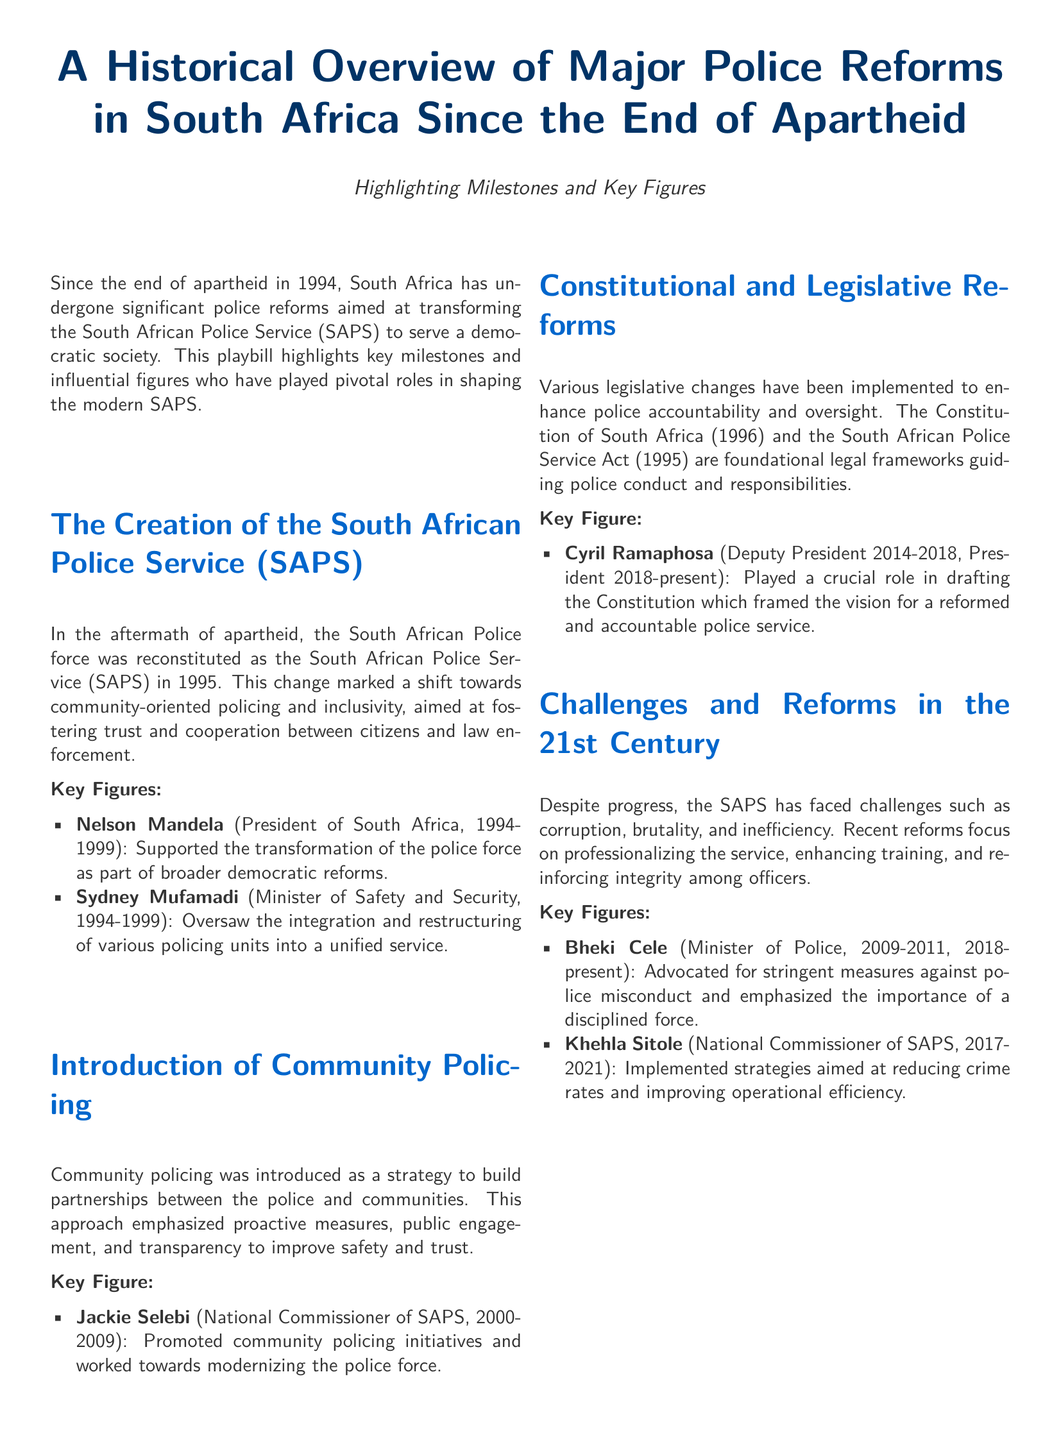What year was the South African Police Service (SAPS) created? The document states that the SAPS was reconstituted in 1995 following the end of apartheid.
Answer: 1995 Who served as the President of South Africa from 1994 to 1999? Nelson Mandela is identified as the President during this period and supported police transformation.
Answer: Nelson Mandela What major policing strategy was introduced in South Africa following apartheid? The document notes that community policing was introduced as a strategy to foster relationships between police and communities.
Answer: Community policing Which legislative framework guides police conduct in South Africa? The document mentions the Constitution of South Africa (1996) and the South African Police Service Act (1995) as foundational legal frameworks.
Answer: The Constitution of South Africa and the South African Police Service Act Who was the National Commissioner of SAPS from 2000 to 2009? Jackie Selebi is mentioned as the National Commissioner who promoted community policing initiatives during this time.
Answer: Jackie Selebi Which key figure is associated with addressing police corruption in the 21st century? The document identifies Bheki Cele as a key figure advocating against police misconduct and promoting discipline.
Answer: Bheki Cele How many key figures are mentioned in the document? By counting the key figures listed in the sections, we find a total of six individuals referenced.
Answer: Six What overarching theme does the conclusion of the document emphasize? The conclusion reflects ongoing efforts towards transparency, accountability, and principles of justice in SAPS.
Answer: Transparency and accountability What type of document is this playbill focused on? The document focuses on the historical overview and reforms in the South African Police Service.
Answer: Major police reforms in South Africa 